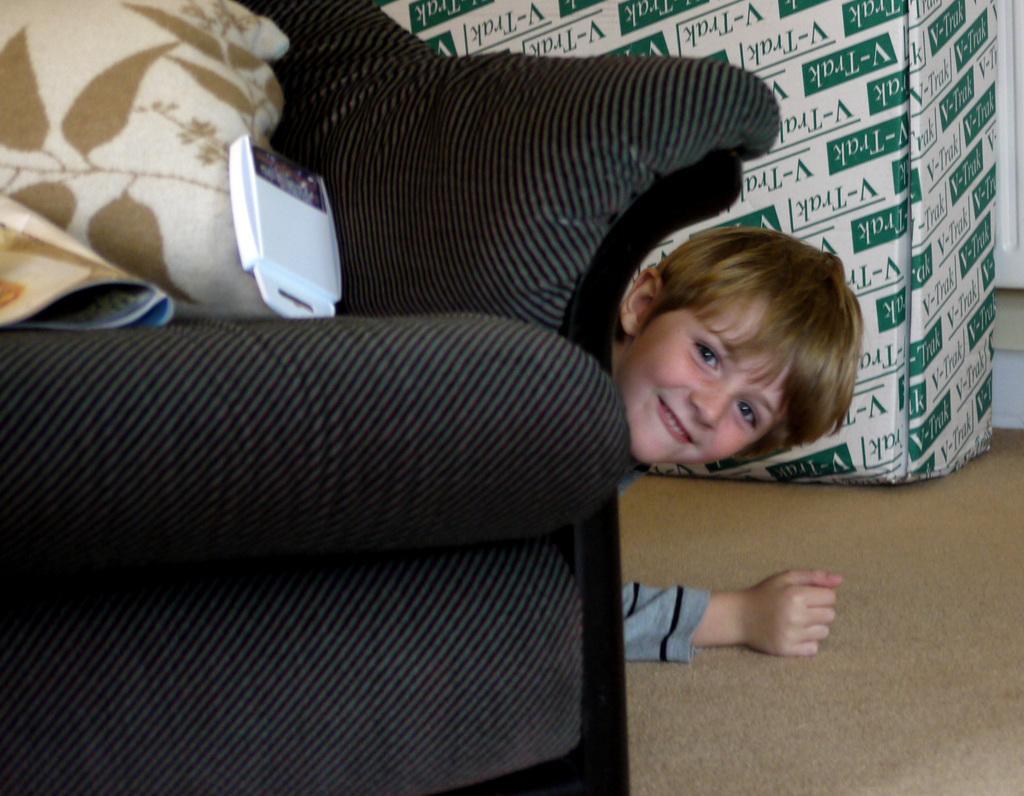Can you describe this image briefly? In this picture we can see a sofa with pillows and a device on it and aside to this sofa we have a boy on ground and he is smiling and beside to him we have a cardboard box. 